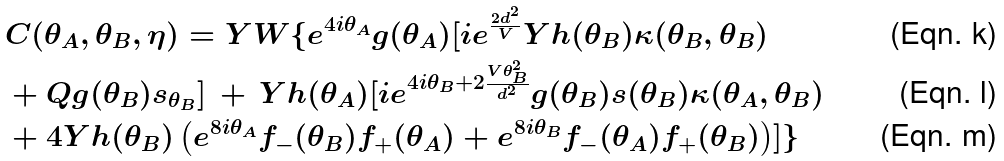Convert formula to latex. <formula><loc_0><loc_0><loc_500><loc_500>& C ( \theta _ { A } , \theta _ { B } , \eta ) = Y W \{ e ^ { 4 i \theta _ { A } } g ( \theta _ { A } ) [ i e ^ { \frac { 2 d ^ { 2 } } { V } } Y h ( \theta _ { B } ) \kappa ( \theta _ { B } , \theta _ { B } ) \\ & + Q g ( \theta _ { B } ) s _ { \theta _ { B } } ] \, + \, Y h ( \theta _ { A } ) [ i e ^ { 4 i \theta _ { B } + 2 \frac { V \theta ^ { 2 } _ { B } } { d ^ { 2 } } } g ( \theta _ { B } ) s ( \theta _ { B } ) \kappa ( \theta _ { A } , \theta _ { B } ) \\ & + 4 Y h ( \theta _ { B } ) \left ( e ^ { 8 i \theta _ { A } } f _ { - } ( \theta _ { B } ) f _ { + } ( \theta _ { A } ) + e ^ { 8 i \theta _ { B } } f _ { - } ( \theta _ { A } ) f _ { + } ( \theta _ { B } ) \right ) ] \}</formula> 